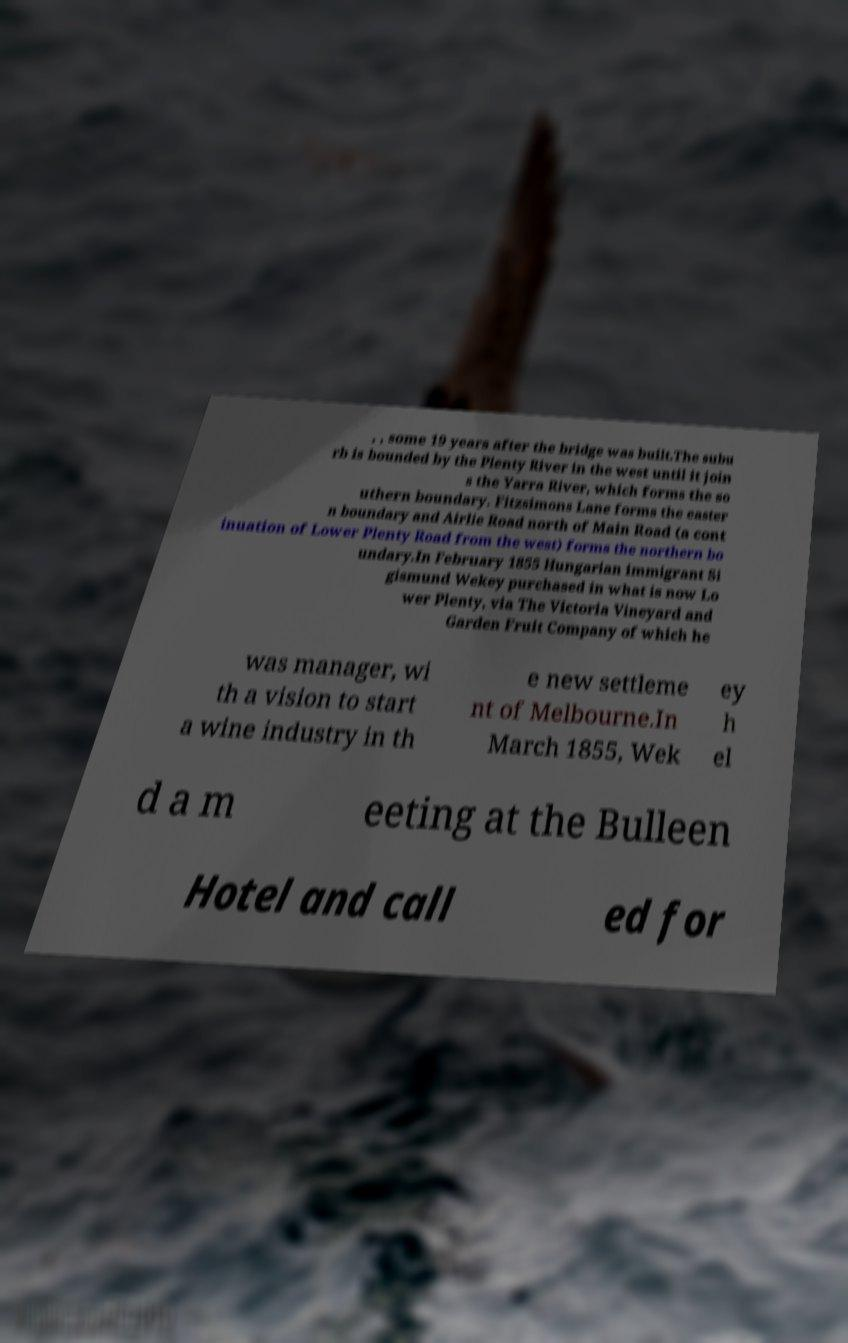I need the written content from this picture converted into text. Can you do that? , , some 19 years after the bridge was built.The subu rb is bounded by the Plenty River in the west until it join s the Yarra River, which forms the so uthern boundary. Fitzsimons Lane forms the easter n boundary and Airlie Road north of Main Road (a cont inuation of Lower Plenty Road from the west) forms the northern bo undary.In February 1855 Hungarian immigrant Si gismund Wekey purchased in what is now Lo wer Plenty, via The Victoria Vineyard and Garden Fruit Company of which he was manager, wi th a vision to start a wine industry in th e new settleme nt of Melbourne.In March 1855, Wek ey h el d a m eeting at the Bulleen Hotel and call ed for 